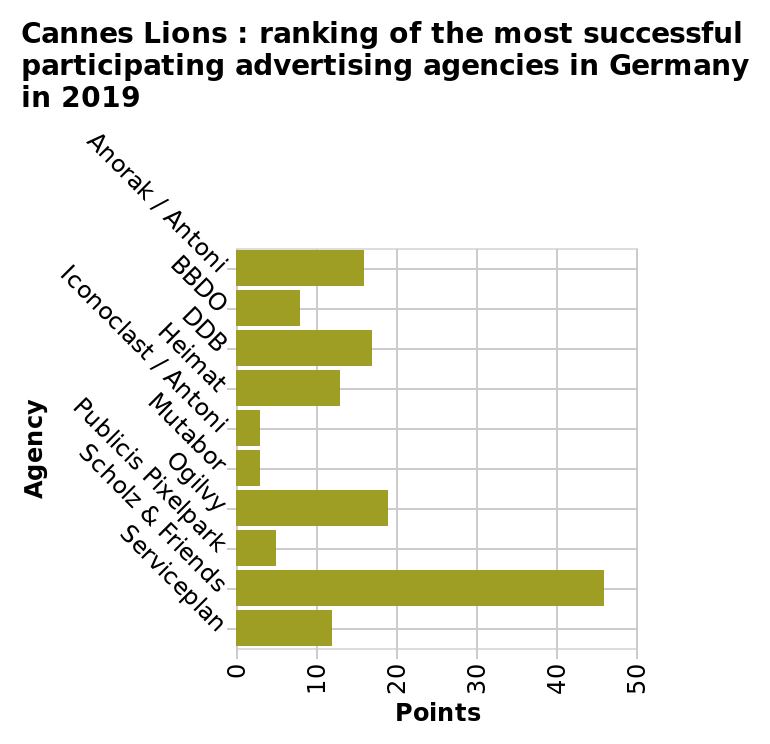<image>
Which agency had the lowest score according to the Cannes Lions Ranking? The lowest-ranked agency. What is the title of the bar plot?  The title of the bar plot is "Cannes Lions: ranking of the most successful participating advertising agencies in Germany in 2019". What was the difference in score between the highest-ranked agency and the lowest-ranked agency according to the Cannes Lions Ranking? 43 points. 